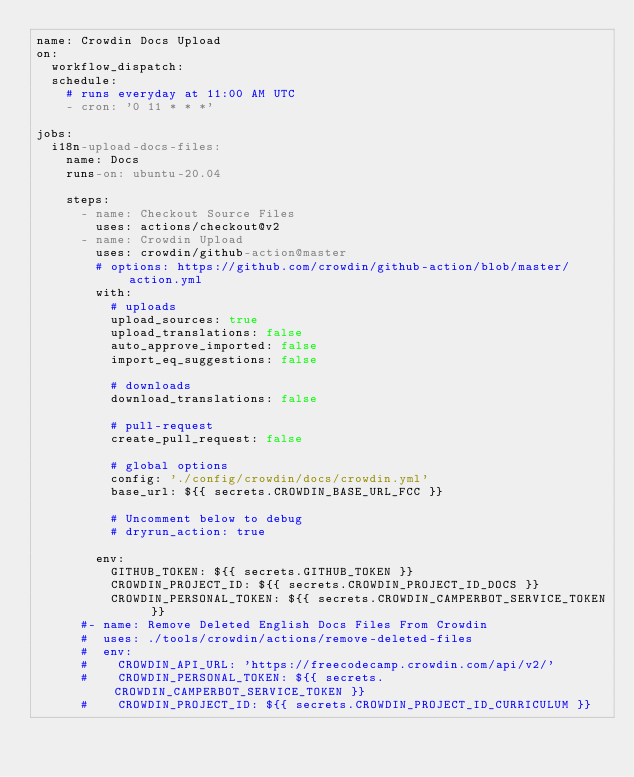Convert code to text. <code><loc_0><loc_0><loc_500><loc_500><_YAML_>name: Crowdin Docs Upload
on:
  workflow_dispatch:
  schedule:
    # runs everyday at 11:00 AM UTC
    - cron: '0 11 * * *'

jobs:
  i18n-upload-docs-files:
    name: Docs
    runs-on: ubuntu-20.04

    steps:
      - name: Checkout Source Files
        uses: actions/checkout@v2
      - name: Crowdin Upload
        uses: crowdin/github-action@master
        # options: https://github.com/crowdin/github-action/blob/master/action.yml
        with:
          # uploads
          upload_sources: true
          upload_translations: false
          auto_approve_imported: false
          import_eq_suggestions: false

          # downloads
          download_translations: false

          # pull-request
          create_pull_request: false

          # global options
          config: './config/crowdin/docs/crowdin.yml'
          base_url: ${{ secrets.CROWDIN_BASE_URL_FCC }}

          # Uncomment below to debug
          # dryrun_action: true

        env:
          GITHUB_TOKEN: ${{ secrets.GITHUB_TOKEN }}
          CROWDIN_PROJECT_ID: ${{ secrets.CROWDIN_PROJECT_ID_DOCS }}
          CROWDIN_PERSONAL_TOKEN: ${{ secrets.CROWDIN_CAMPERBOT_SERVICE_TOKEN }}
      #- name: Remove Deleted English Docs Files From Crowdin
      #  uses: ./tools/crowdin/actions/remove-deleted-files
      #  env:
      #    CROWDIN_API_URL: 'https://freecodecamp.crowdin.com/api/v2/'
      #    CROWDIN_PERSONAL_TOKEN: ${{ secrets.CROWDIN_CAMPERBOT_SERVICE_TOKEN }}
      #    CROWDIN_PROJECT_ID: ${{ secrets.CROWDIN_PROJECT_ID_CURRICULUM }}
</code> 